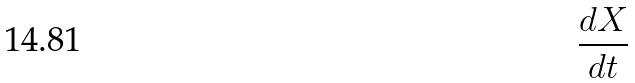Convert formula to latex. <formula><loc_0><loc_0><loc_500><loc_500>\frac { d X } { d t }</formula> 